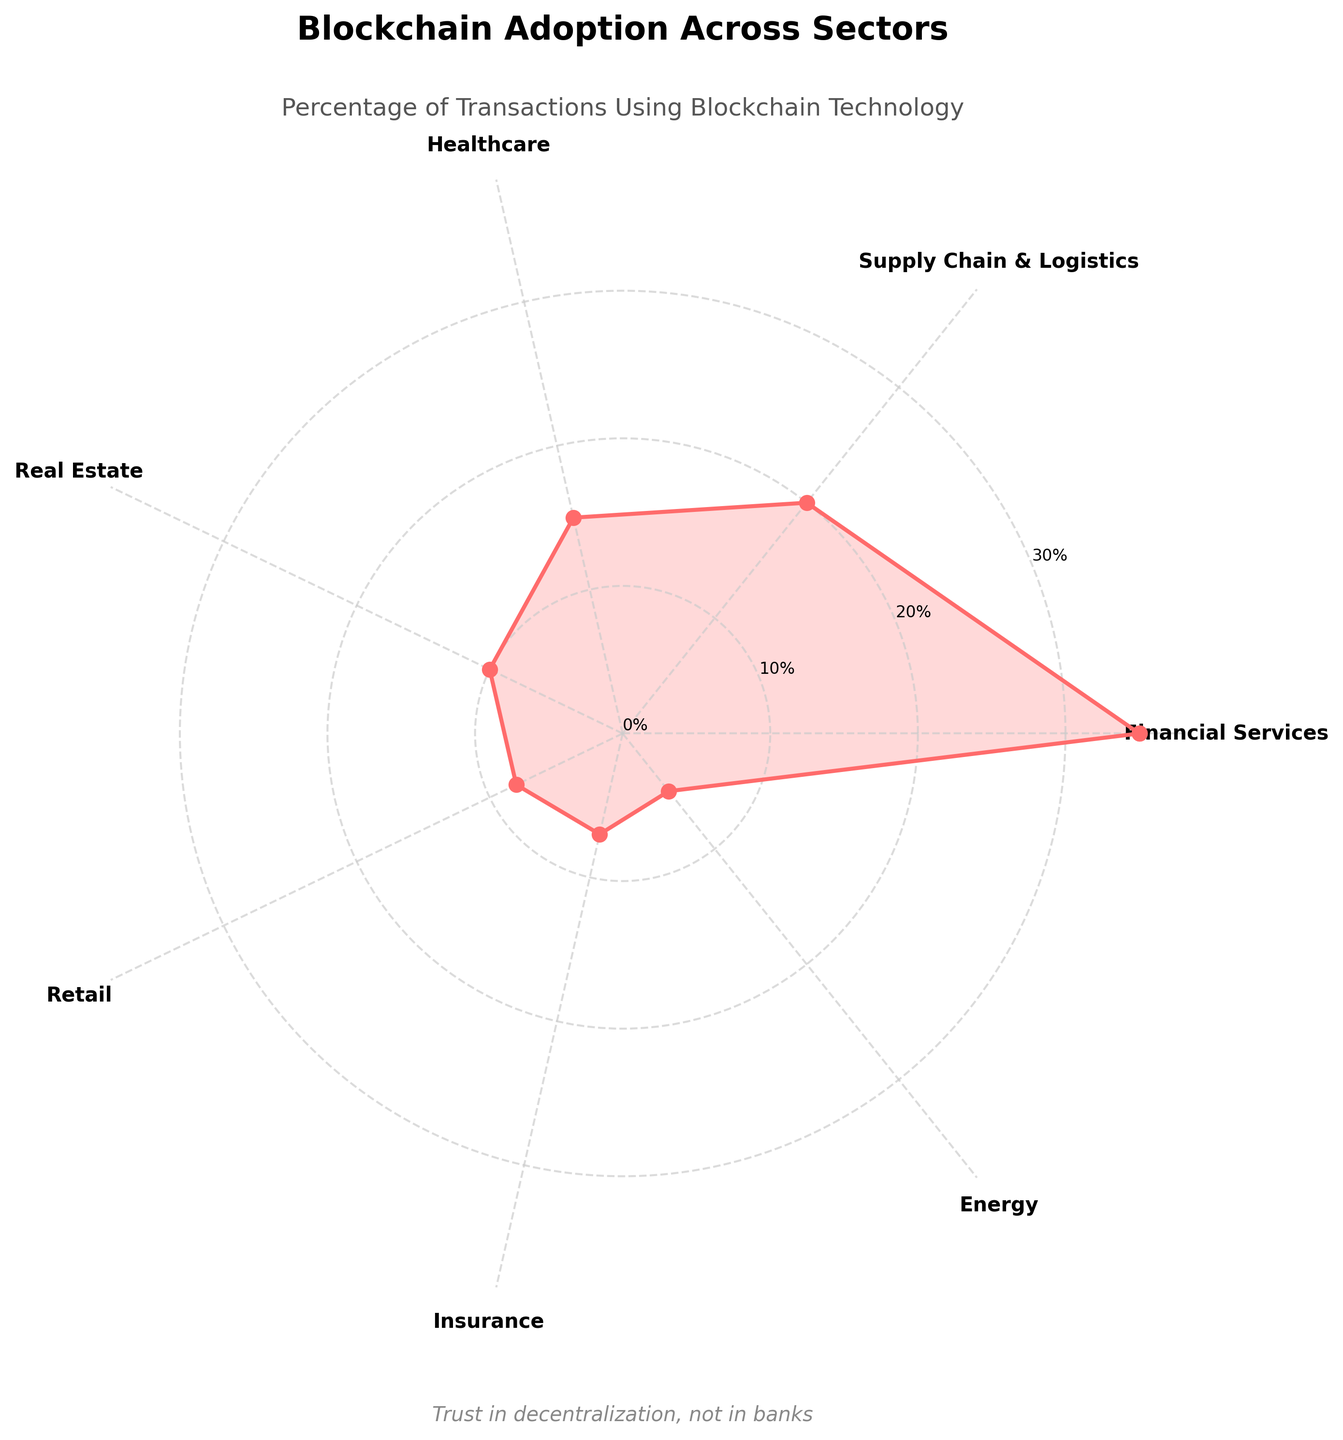What is the sector with the highest percentage of transactions using blockchain technology? The highest percentage value represented in the chart corresponds to Financial Services, which is indicated at 35%.
Answer: Financial Services What is the smallest percentage segment in the chart? The chart shows the smallest segment with a value of 5%, which belongs to the Energy sector.
Answer: Energy What is the total percentage of transactions using blockchain technology in Supply Chain & Logistics and Healthcare? Sum the percentages for Supply Chain & Logistics (20%) and Healthcare (15%), which equals 20% + 15% = 35%.
Answer: 35% Which sectors are represented by segments that are less than or equal to 10%? The chart shows that Real Estate (10%), Retail (8%), Insurance (7%), and Energy (5%) all have segments that are less than or equal to 10%.
Answer: Real Estate, Retail, Insurance, and Energy How does the percentage of transactions in Financial Services compare to that in Real Estate? Compare the percentages for Financial Services (35%) and Real Estate (10%). Financial Services has a higher percentage than Real Estate by 35% - 10% = 25%.
Answer: Financial Services is 25% higher What is the average percentage of transactions using blockchain technology across all sectors? Sum all the percentages (35 + 20 + 15 + 10 + 8 + 7 + 5 = 100) and divide by the number of sectors (7). The average is 100 / 7 ≈ 14.29%.
Answer: 14.29% Which sector's adoption rate is closest to the average adoption rate across all sectors? Calculate the average adoption rate (100 / 7 ≈ 14.29%) and find the sector closest to this value. Healthcare at 15% is closest to the average.
Answer: Healthcare If you combined the percentages of Retail and Insurance, how would it compare to Healthcare? Sum the percentages of Retail (8%) and Insurance (7%) to get 15%, which matches the percentage of Healthcare.
Answer: Equal What sectors have transaction percentages that are at least twice the percentage of Retail? Identify sectors with percentages at least 16% (twice of Retail 8%). These sectors are Financial Services (35%), Supply Chain & Logistics (20%), and Healthcare (15%).
Answer: Financial Services, Supply Chain & Logistics, and Healthcare Between Supply Chain & Logistics and Energy, which sector has a higher percentage and by how much? Compare the percentages of Supply Chain & Logistics (20%) and Energy (5%). Supply Chain & Logistics is higher by 20% - 5% = 15%.
Answer: Supply Chain & Logistics by 15% 